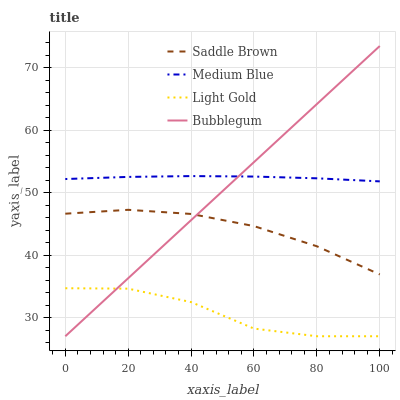Does Light Gold have the minimum area under the curve?
Answer yes or no. Yes. Does Medium Blue have the maximum area under the curve?
Answer yes or no. Yes. Does Saddle Brown have the minimum area under the curve?
Answer yes or no. No. Does Saddle Brown have the maximum area under the curve?
Answer yes or no. No. Is Bubblegum the smoothest?
Answer yes or no. Yes. Is Light Gold the roughest?
Answer yes or no. Yes. Is Medium Blue the smoothest?
Answer yes or no. No. Is Medium Blue the roughest?
Answer yes or no. No. Does Light Gold have the lowest value?
Answer yes or no. Yes. Does Saddle Brown have the lowest value?
Answer yes or no. No. Does Bubblegum have the highest value?
Answer yes or no. Yes. Does Medium Blue have the highest value?
Answer yes or no. No. Is Saddle Brown less than Medium Blue?
Answer yes or no. Yes. Is Medium Blue greater than Light Gold?
Answer yes or no. Yes. Does Bubblegum intersect Medium Blue?
Answer yes or no. Yes. Is Bubblegum less than Medium Blue?
Answer yes or no. No. Is Bubblegum greater than Medium Blue?
Answer yes or no. No. Does Saddle Brown intersect Medium Blue?
Answer yes or no. No. 